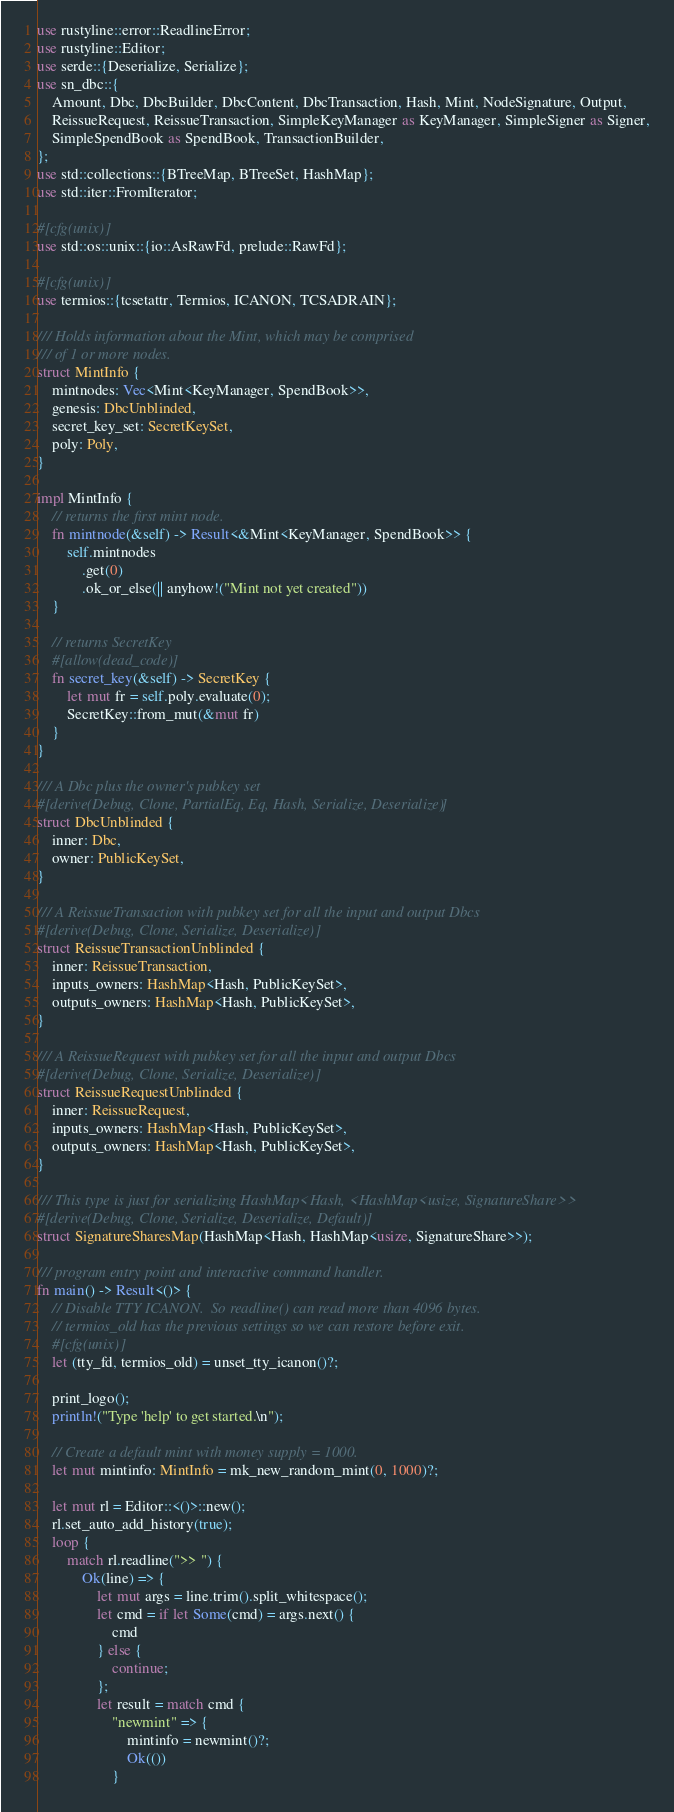Convert code to text. <code><loc_0><loc_0><loc_500><loc_500><_Rust_>use rustyline::error::ReadlineError;
use rustyline::Editor;
use serde::{Deserialize, Serialize};
use sn_dbc::{
    Amount, Dbc, DbcBuilder, DbcContent, DbcTransaction, Hash, Mint, NodeSignature, Output,
    ReissueRequest, ReissueTransaction, SimpleKeyManager as KeyManager, SimpleSigner as Signer,
    SimpleSpendBook as SpendBook, TransactionBuilder,
};
use std::collections::{BTreeMap, BTreeSet, HashMap};
use std::iter::FromIterator;

#[cfg(unix)]
use std::os::unix::{io::AsRawFd, prelude::RawFd};

#[cfg(unix)]
use termios::{tcsetattr, Termios, ICANON, TCSADRAIN};

/// Holds information about the Mint, which may be comprised
/// of 1 or more nodes.
struct MintInfo {
    mintnodes: Vec<Mint<KeyManager, SpendBook>>,
    genesis: DbcUnblinded,
    secret_key_set: SecretKeySet,
    poly: Poly,
}

impl MintInfo {
    // returns the first mint node.
    fn mintnode(&self) -> Result<&Mint<KeyManager, SpendBook>> {
        self.mintnodes
            .get(0)
            .ok_or_else(|| anyhow!("Mint not yet created"))
    }

    // returns SecretKey
    #[allow(dead_code)]
    fn secret_key(&self) -> SecretKey {
        let mut fr = self.poly.evaluate(0);
        SecretKey::from_mut(&mut fr)
    }
}

/// A Dbc plus the owner's pubkey set
#[derive(Debug, Clone, PartialEq, Eq, Hash, Serialize, Deserialize)]
struct DbcUnblinded {
    inner: Dbc,
    owner: PublicKeySet,
}

/// A ReissueTransaction with pubkey set for all the input and output Dbcs
#[derive(Debug, Clone, Serialize, Deserialize)]
struct ReissueTransactionUnblinded {
    inner: ReissueTransaction,
    inputs_owners: HashMap<Hash, PublicKeySet>,
    outputs_owners: HashMap<Hash, PublicKeySet>,
}

/// A ReissueRequest with pubkey set for all the input and output Dbcs
#[derive(Debug, Clone, Serialize, Deserialize)]
struct ReissueRequestUnblinded {
    inner: ReissueRequest,
    inputs_owners: HashMap<Hash, PublicKeySet>,
    outputs_owners: HashMap<Hash, PublicKeySet>,
}

/// This type is just for serializing HashMap<Hash, <HashMap<usize, SignatureShare>>
#[derive(Debug, Clone, Serialize, Deserialize, Default)]
struct SignatureSharesMap(HashMap<Hash, HashMap<usize, SignatureShare>>);

/// program entry point and interactive command handler.
fn main() -> Result<()> {
    // Disable TTY ICANON.  So readline() can read more than 4096 bytes.
    // termios_old has the previous settings so we can restore before exit.
    #[cfg(unix)]
    let (tty_fd, termios_old) = unset_tty_icanon()?;

    print_logo();
    println!("Type 'help' to get started.\n");

    // Create a default mint with money supply = 1000.
    let mut mintinfo: MintInfo = mk_new_random_mint(0, 1000)?;

    let mut rl = Editor::<()>::new();
    rl.set_auto_add_history(true);
    loop {
        match rl.readline(">> ") {
            Ok(line) => {
                let mut args = line.trim().split_whitespace();
                let cmd = if let Some(cmd) = args.next() {
                    cmd
                } else {
                    continue;
                };
                let result = match cmd {
                    "newmint" => {
                        mintinfo = newmint()?;
                        Ok(())
                    }</code> 